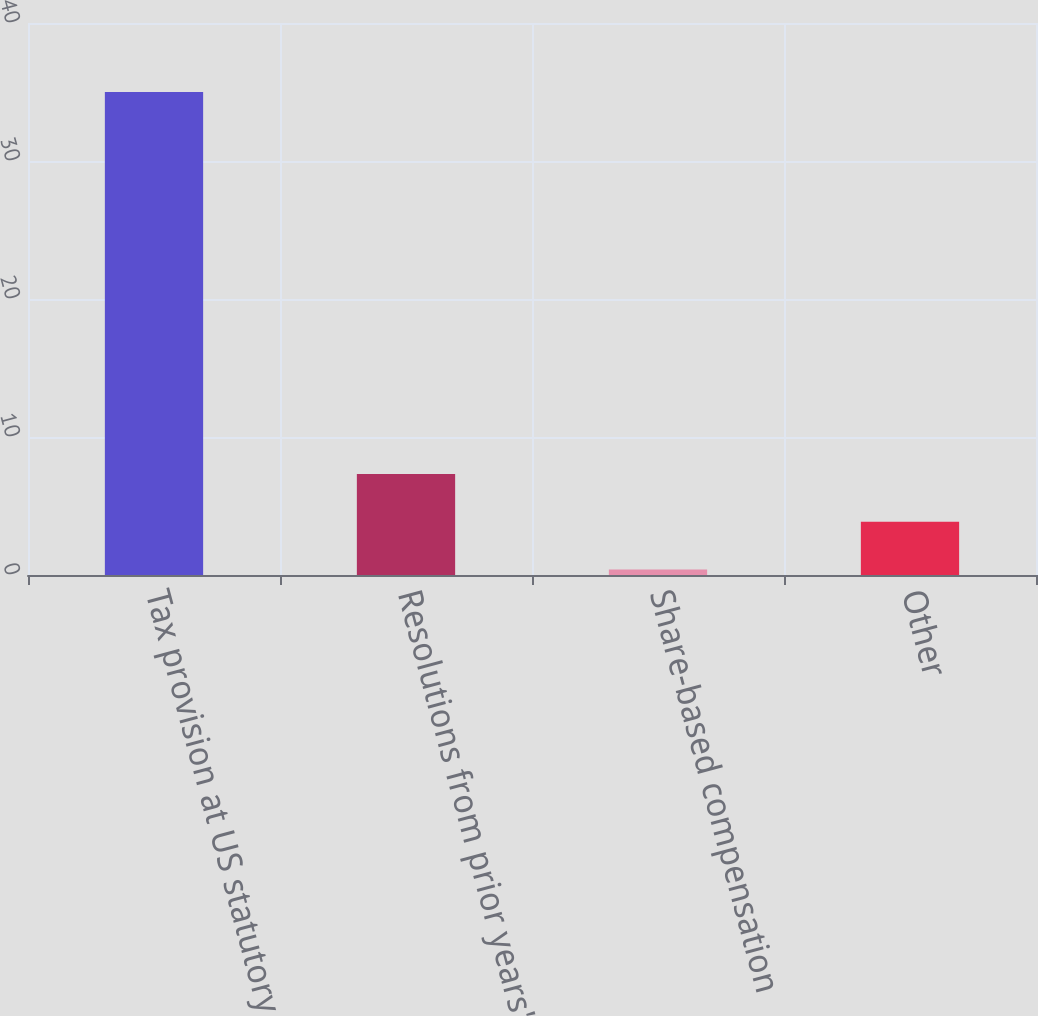Convert chart to OTSL. <chart><loc_0><loc_0><loc_500><loc_500><bar_chart><fcel>Tax provision at US statutory<fcel>Resolutions from prior years'<fcel>Share-based compensation<fcel>Other<nl><fcel>35<fcel>7.32<fcel>0.4<fcel>3.86<nl></chart> 